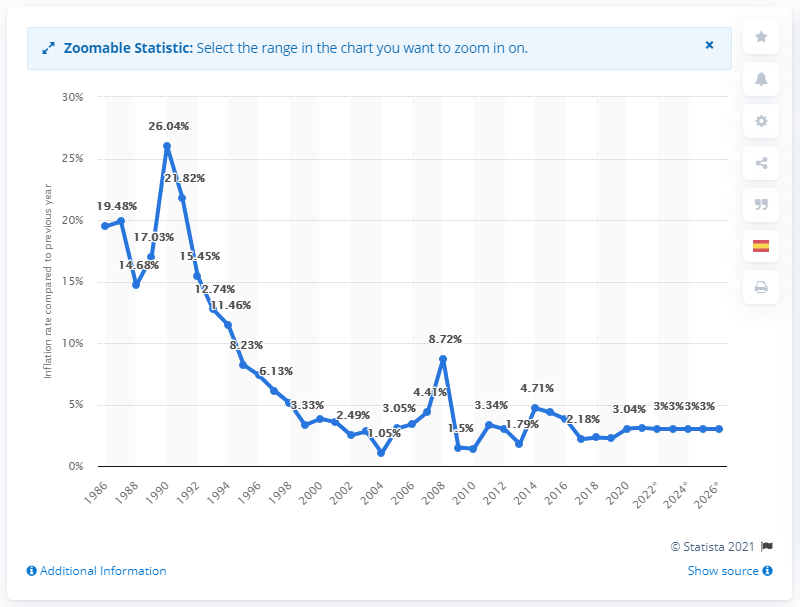Give some essential details in this illustration. In 2020, the inflation rate in Chile was 3.04%. 